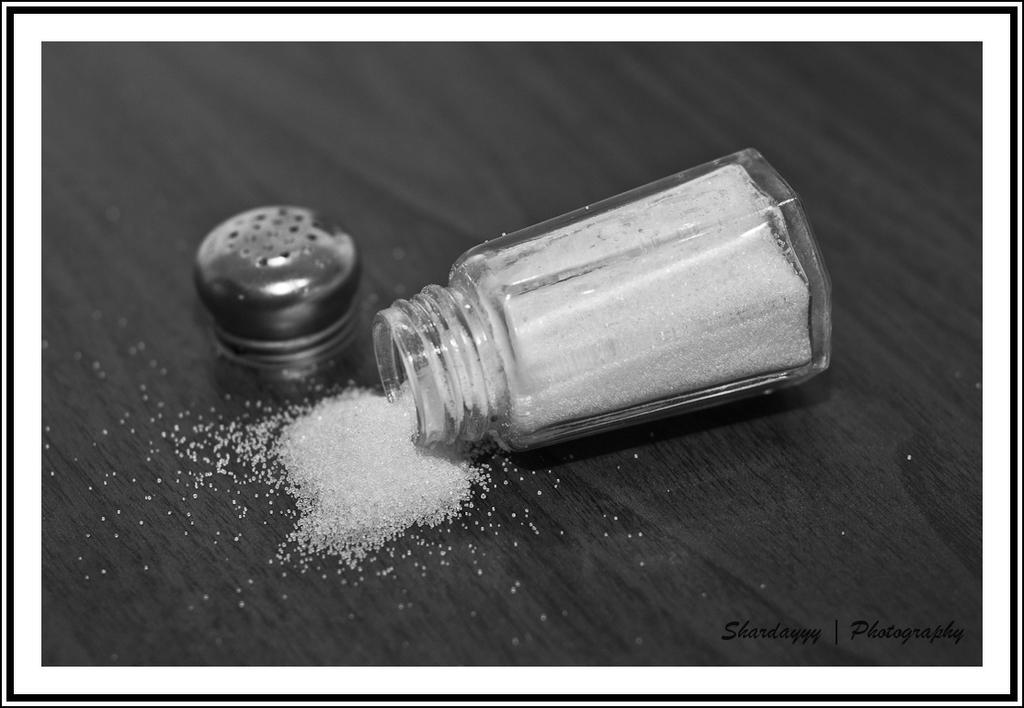Please provide a concise description of this image. This is a black and white image and here we can see jar containing sugar and we can see a cap, which are on the table. At the bottom, there is some text. 